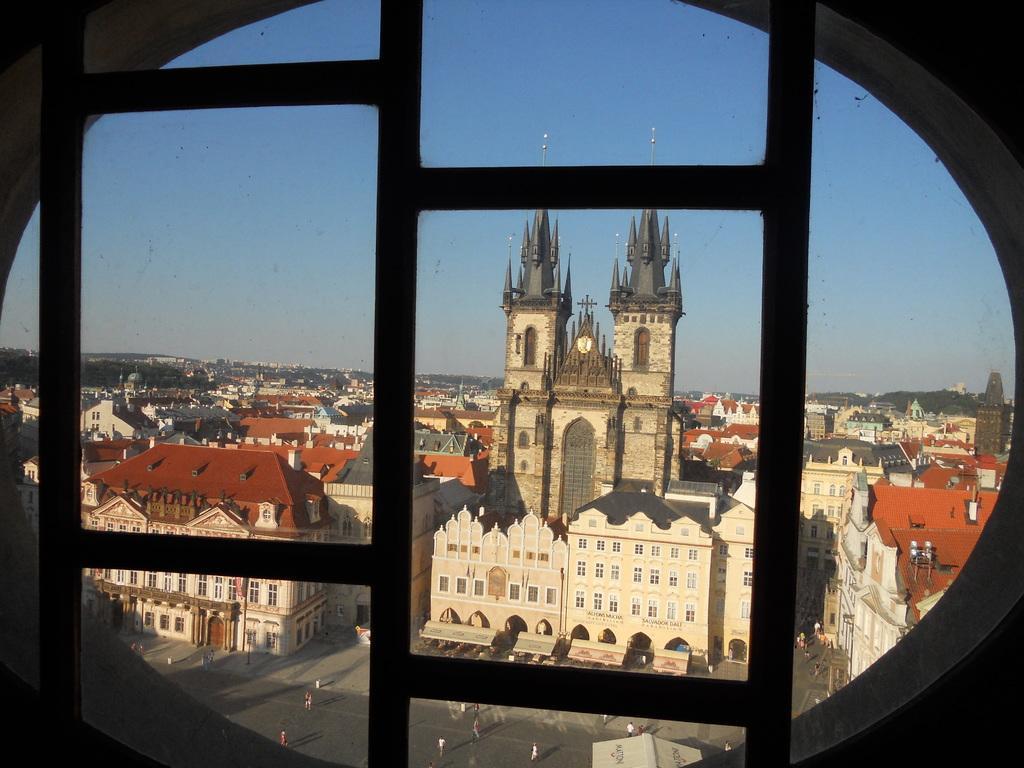In one or two sentences, can you explain what this image depicts? In this picture we can see buildings, trees, and few people. In the background there is sky. 